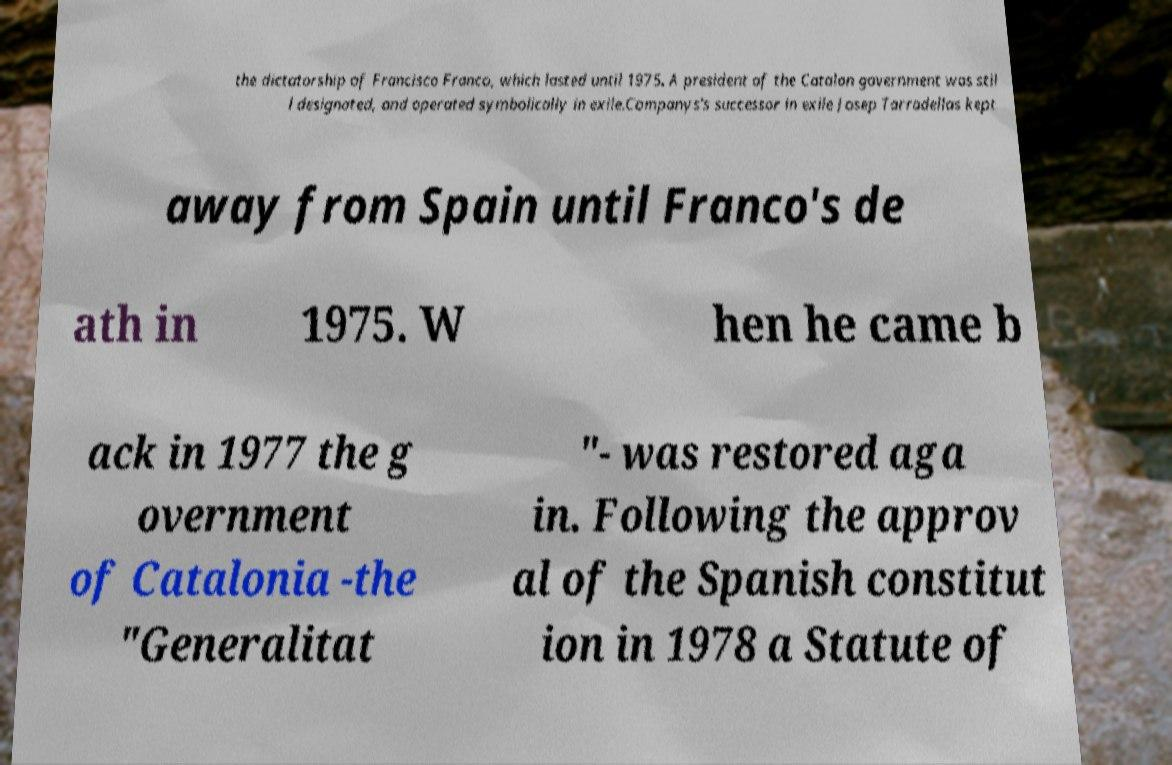What messages or text are displayed in this image? I need them in a readable, typed format. the dictatorship of Francisco Franco, which lasted until 1975. A president of the Catalan government was stil l designated, and operated symbolically in exile.Companys's successor in exile Josep Tarradellas kept away from Spain until Franco's de ath in 1975. W hen he came b ack in 1977 the g overnment of Catalonia -the "Generalitat "- was restored aga in. Following the approv al of the Spanish constitut ion in 1978 a Statute of 